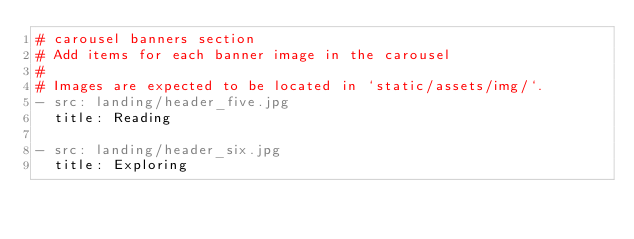Convert code to text. <code><loc_0><loc_0><loc_500><loc_500><_YAML_># carousel banners section
# Add items for each banner image in the carousel
#
# Images are expected to be located in `static/assets/img/`.
- src: landing/header_five.jpg
  title: Reading

- src: landing/header_six.jpg
  title: Exploring</code> 